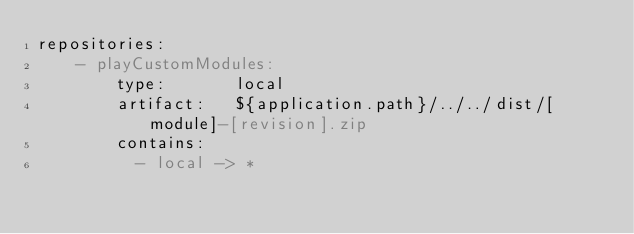<code> <loc_0><loc_0><loc_500><loc_500><_YAML_>repositories:
    - playCustomModules:
        type:       local
        artifact:   ${application.path}/../../dist/[module]-[revision].zip
        contains:
          - local -> *
</code> 